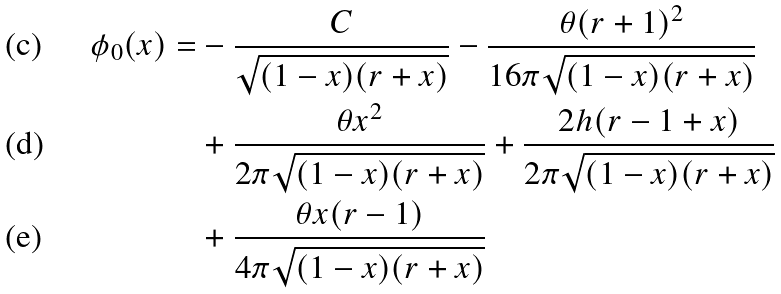Convert formula to latex. <formula><loc_0><loc_0><loc_500><loc_500>\phi _ { 0 } ( x ) = & - \frac { C } { \sqrt { ( 1 - x ) ( r + x ) } } - \frac { \theta ( r + 1 ) ^ { 2 } } { 1 6 \pi \sqrt { ( 1 - x ) ( r + x ) } } \\ & + \frac { \theta x ^ { 2 } } { 2 \pi \sqrt { ( 1 - x ) ( r + x ) } } + \frac { 2 h ( r - 1 + x ) } { 2 \pi \sqrt { ( 1 - x ) ( r + x ) } } \\ & + \frac { \theta x ( r - 1 ) } { 4 \pi \sqrt { ( 1 - x ) ( r + x ) } }</formula> 